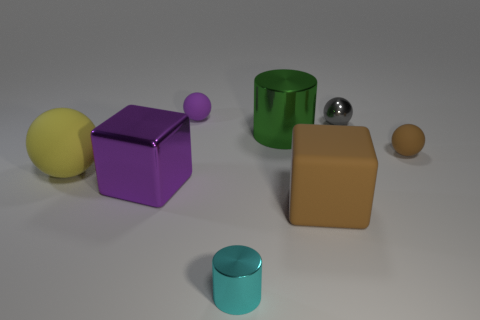Are there any other large rubber blocks of the same color as the large matte cube?
Provide a succinct answer. No. There is a purple thing that is made of the same material as the big yellow thing; what size is it?
Ensure brevity in your answer.  Small. Is the color of the matte cube the same as the shiny ball?
Your response must be concise. No. There is a purple object that is in front of the small brown rubber object; is its shape the same as the purple matte object?
Make the answer very short. No. How many yellow objects are the same size as the cyan shiny cylinder?
Provide a short and direct response. 0. What is the shape of the matte thing that is the same color as the big metal block?
Your answer should be very brief. Sphere. Is there a large matte thing that is on the left side of the purple thing in front of the green metal cylinder?
Give a very brief answer. Yes. How many objects are either tiny matte things right of the tiny gray shiny object or large matte things?
Make the answer very short. 3. How many small gray metal spheres are there?
Offer a terse response. 1. There is a big purple object that is made of the same material as the large cylinder; what is its shape?
Give a very brief answer. Cube. 